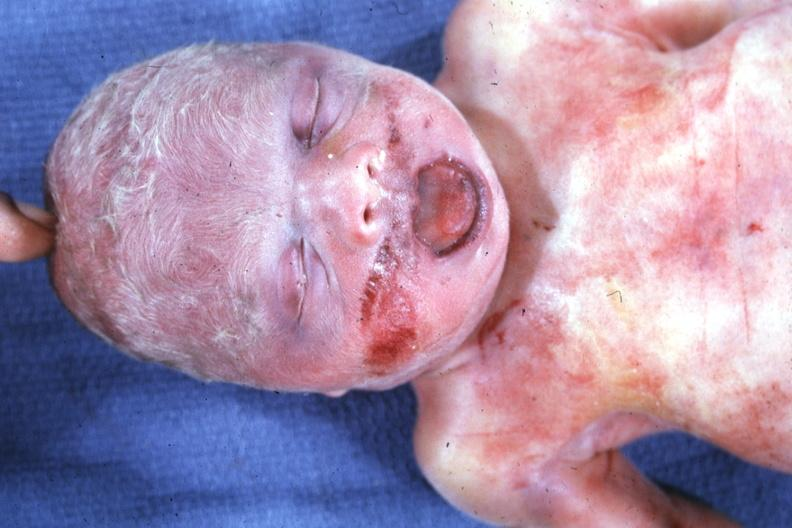s face present?
Answer the question using a single word or phrase. Yes 